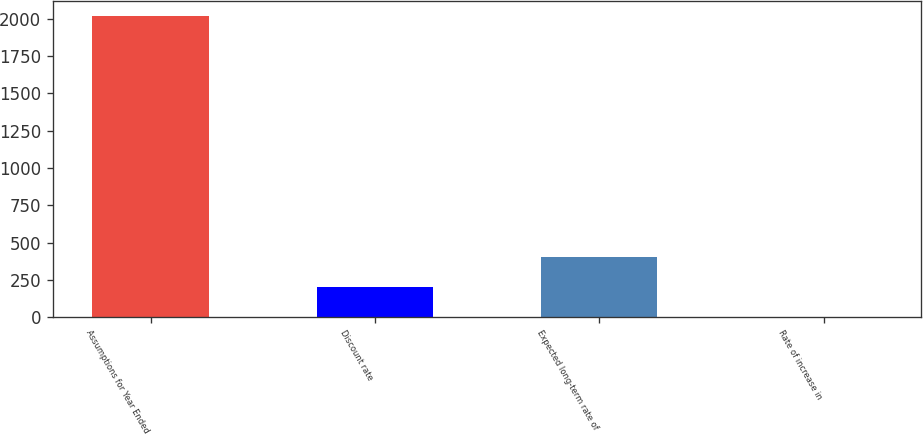Convert chart. <chart><loc_0><loc_0><loc_500><loc_500><bar_chart><fcel>Assumptions for Year Ended<fcel>Discount rate<fcel>Expected long-term rate of<fcel>Rate of increase in<nl><fcel>2015<fcel>204.59<fcel>405.75<fcel>3.43<nl></chart> 